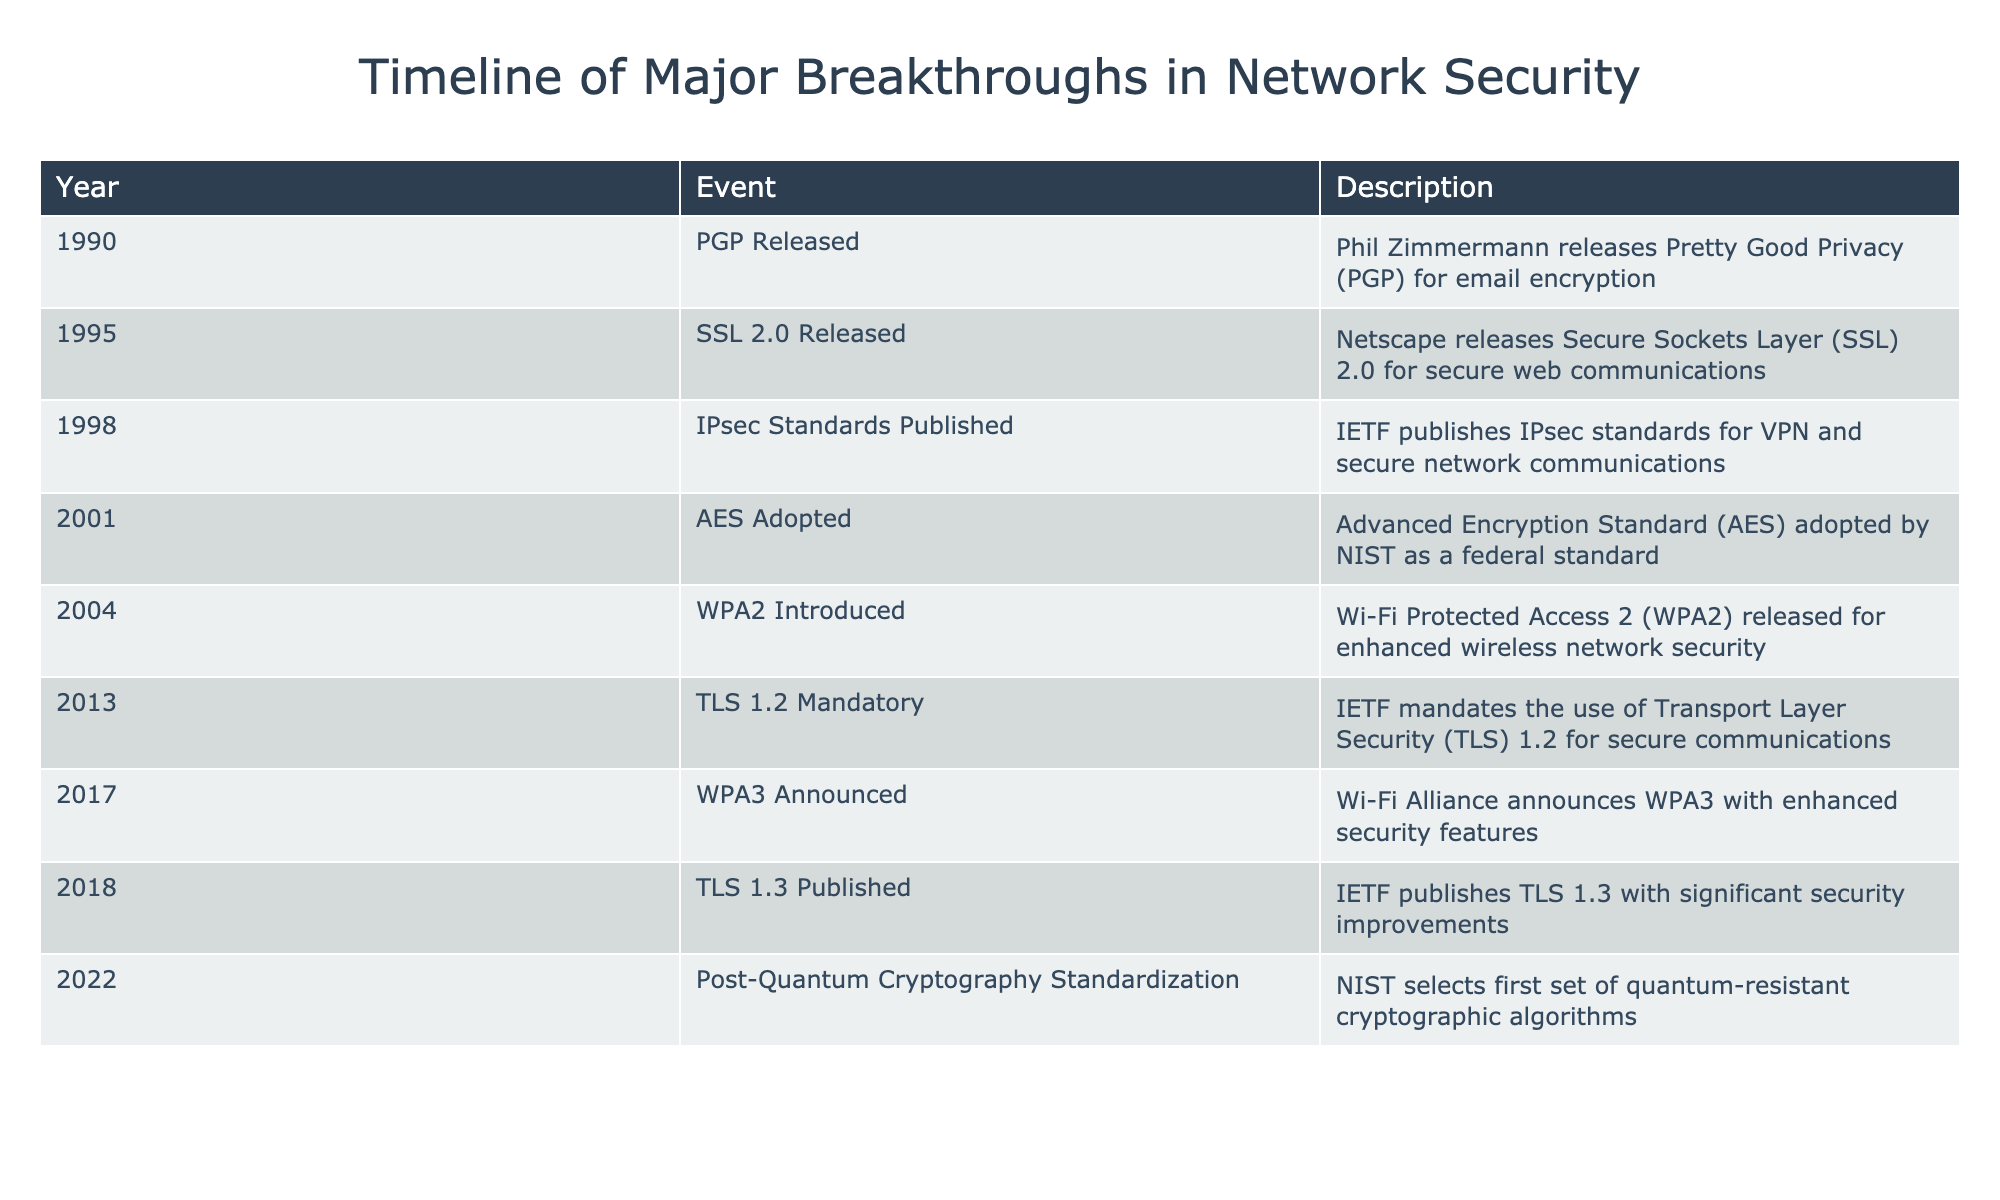What year was PGP released? The table lists the event "PGP Released" under the year 1990. This means PGP was released in that year.
Answer: 1990 Which event occurred right after AES was adopted? After the event "AES Adopted" in 2001, the next event listed in the table is "WPA2 Introduced" in 2004, which means WPA2 was the event that followed AES adoption.
Answer: WPA2 Introduced How many years are between the introduction of SSL 2.0 and IPsec standards? SSL 2.0 was released in 1995 and IPsec standards were published in 1998. The difference is 1998 - 1995 = 3 years.
Answer: 3 years Is TLS 1.3 published after WPA3 was announced? TLS 1.3 was published in 2018, while WPA3 was announced in 2017. Since 2018 is after 2017, the statement is true.
Answer: Yes What is the average year when the key breakthroughs occurred in network security, based on the timeline provided? To find the average year, sum the years: 1990 + 1995 + 1998 + 2001 + 2004 + 2013 + 2017 + 2018 + 2022 = 2010. Dividing by the total number of events (9), we find that the average year is approximately 2010.
Answer: 2010 Which event marks the transition to post-quantum cryptography standards? The event "Post-Quantum Cryptography Standardization" in 2022 signifies the transition to post-quantum cryptography standards in the timeline.
Answer: Post-Quantum Cryptography Standardization What percentage of the listed events are related to encryption standards? There are 5 events directly related to encryption standards (PGP, AES, TLS 1.2, TLS 1.3, and Post-Quantum Cryptography). The total number of events is 9, so (5/9)*100 = 55.56%.
Answer: 55.56% How many major breakthroughs occurred in the 2010s? Examining the table, the years 2013, 2017, and 2018 are all in the 2010s, totaling 3 breakthroughs in that decade.
Answer: 3 breakthroughs What year did WPA2 come out, and was it more than 10 years after SSL 2.0? WPA2 was introduced in 2004, while SSL 2.0 was released in 1995. The difference is 2004 - 1995 = 9 years, which is less than 10.
Answer: No 